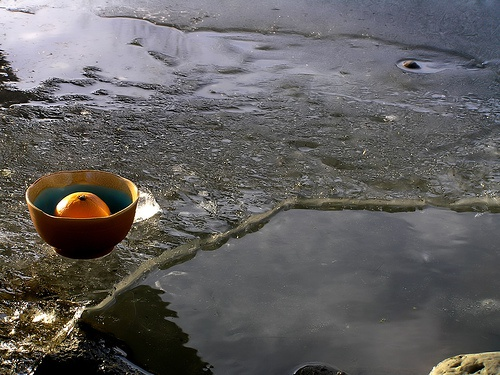Describe the objects in this image and their specific colors. I can see bowl in darkgray, black, and maroon tones and orange in darkgray, maroon, brown, and red tones in this image. 